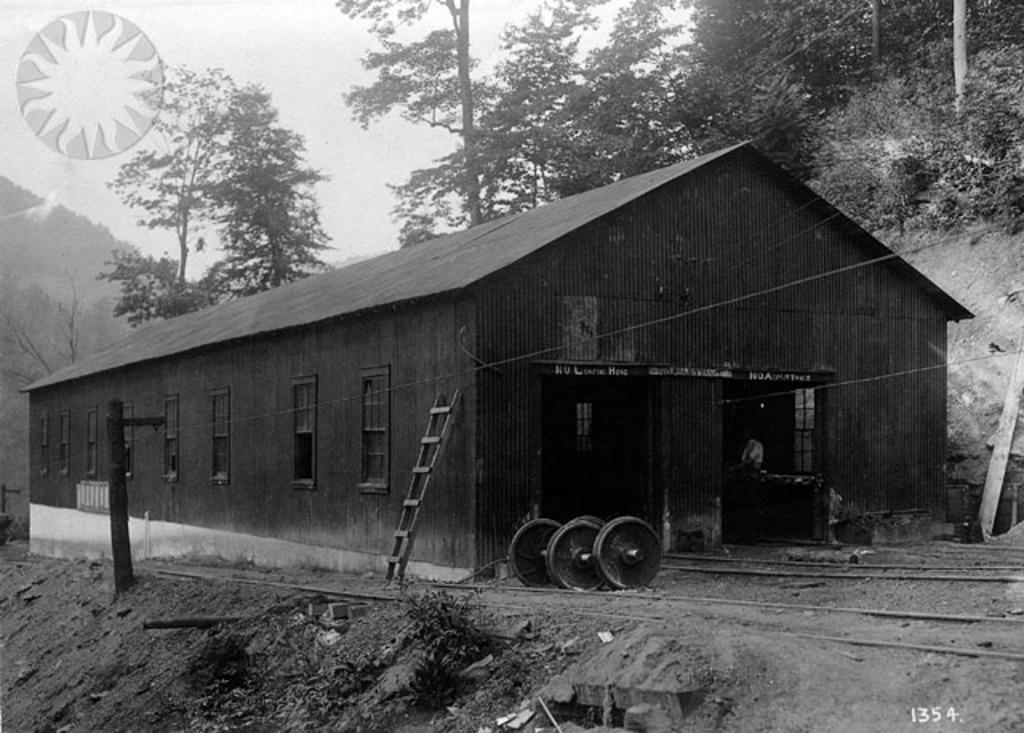What is the color scheme of the image? The image is black and white. What type of structure can be seen in the image? There is a shed in the image. What is used for climbing in the image? There is a ladder in the image. What allows light to enter the shed in the image? There are windows in the image. What material is used for the construction of the shed in the image? There are boards in the image. What type of vegetation is visible in the image? There are trees in the image. Is there any text or logo present in the image? Yes, there is a watermark in the image. What is visible in the background of the image? The sky is visible in the background of the image. What type of clouds can be seen in the image? There are no clouds visible in the image, as it is a black and white image with no visible sky. How many daughters are present in the image? There are no people, including daughters, present in the image. 